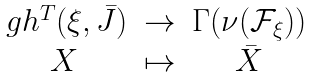Convert formula to latex. <formula><loc_0><loc_0><loc_500><loc_500>\begin{array} { c c c } \ g h ^ { T } ( \xi , \bar { J } ) & \rightarrow & \Gamma ( \nu ( { \mathcal { F } } _ { \xi } ) ) \\ X & \mapsto & \bar { X } \end{array}</formula> 